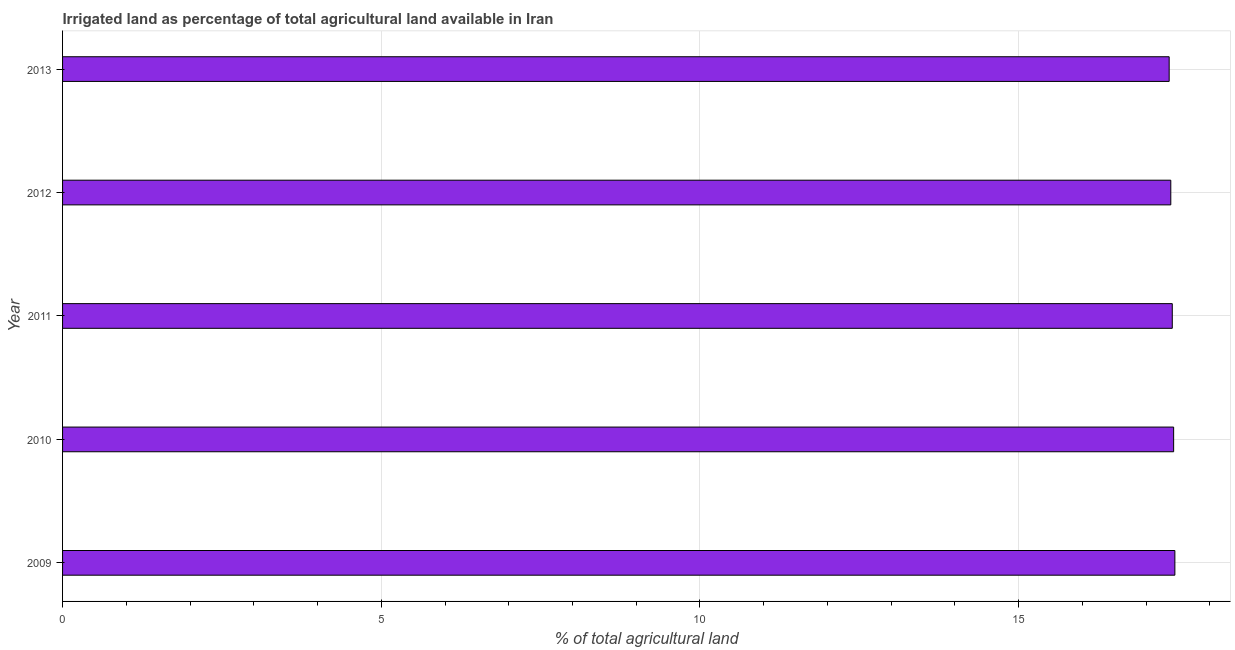Does the graph contain grids?
Give a very brief answer. Yes. What is the title of the graph?
Your answer should be very brief. Irrigated land as percentage of total agricultural land available in Iran. What is the label or title of the X-axis?
Provide a short and direct response. % of total agricultural land. What is the percentage of agricultural irrigated land in 2012?
Provide a short and direct response. 17.39. Across all years, what is the maximum percentage of agricultural irrigated land?
Make the answer very short. 17.45. Across all years, what is the minimum percentage of agricultural irrigated land?
Provide a succinct answer. 17.36. In which year was the percentage of agricultural irrigated land maximum?
Keep it short and to the point. 2009. What is the sum of the percentage of agricultural irrigated land?
Ensure brevity in your answer.  87.04. What is the difference between the percentage of agricultural irrigated land in 2010 and 2012?
Give a very brief answer. 0.04. What is the average percentage of agricultural irrigated land per year?
Make the answer very short. 17.41. What is the median percentage of agricultural irrigated land?
Make the answer very short. 17.41. What is the ratio of the percentage of agricultural irrigated land in 2011 to that in 2012?
Give a very brief answer. 1. Is the percentage of agricultural irrigated land in 2009 less than that in 2013?
Provide a succinct answer. No. What is the difference between the highest and the second highest percentage of agricultural irrigated land?
Offer a very short reply. 0.02. Is the sum of the percentage of agricultural irrigated land in 2009 and 2010 greater than the maximum percentage of agricultural irrigated land across all years?
Make the answer very short. Yes. What is the difference between the highest and the lowest percentage of agricultural irrigated land?
Make the answer very short. 0.09. In how many years, is the percentage of agricultural irrigated land greater than the average percentage of agricultural irrigated land taken over all years?
Your answer should be compact. 3. Are the values on the major ticks of X-axis written in scientific E-notation?
Give a very brief answer. No. What is the % of total agricultural land in 2009?
Your answer should be very brief. 17.45. What is the % of total agricultural land in 2010?
Your response must be concise. 17.43. What is the % of total agricultural land in 2011?
Your response must be concise. 17.41. What is the % of total agricultural land of 2012?
Offer a terse response. 17.39. What is the % of total agricultural land of 2013?
Make the answer very short. 17.36. What is the difference between the % of total agricultural land in 2009 and 2010?
Ensure brevity in your answer.  0.02. What is the difference between the % of total agricultural land in 2009 and 2011?
Your answer should be very brief. 0.04. What is the difference between the % of total agricultural land in 2009 and 2012?
Provide a short and direct response. 0.06. What is the difference between the % of total agricultural land in 2009 and 2013?
Offer a very short reply. 0.09. What is the difference between the % of total agricultural land in 2010 and 2011?
Make the answer very short. 0.02. What is the difference between the % of total agricultural land in 2010 and 2012?
Keep it short and to the point. 0.04. What is the difference between the % of total agricultural land in 2010 and 2013?
Your response must be concise. 0.07. What is the difference between the % of total agricultural land in 2011 and 2012?
Keep it short and to the point. 0.02. What is the difference between the % of total agricultural land in 2011 and 2013?
Make the answer very short. 0.05. What is the difference between the % of total agricultural land in 2012 and 2013?
Offer a terse response. 0.03. What is the ratio of the % of total agricultural land in 2009 to that in 2010?
Provide a short and direct response. 1. What is the ratio of the % of total agricultural land in 2009 to that in 2011?
Your response must be concise. 1. What is the ratio of the % of total agricultural land in 2010 to that in 2011?
Make the answer very short. 1. What is the ratio of the % of total agricultural land in 2010 to that in 2013?
Your answer should be very brief. 1. What is the ratio of the % of total agricultural land in 2011 to that in 2012?
Give a very brief answer. 1. What is the ratio of the % of total agricultural land in 2011 to that in 2013?
Your response must be concise. 1. What is the ratio of the % of total agricultural land in 2012 to that in 2013?
Keep it short and to the point. 1. 